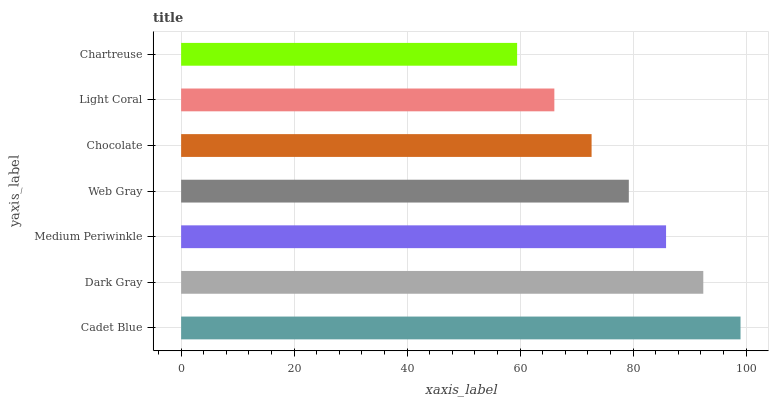Is Chartreuse the minimum?
Answer yes or no. Yes. Is Cadet Blue the maximum?
Answer yes or no. Yes. Is Dark Gray the minimum?
Answer yes or no. No. Is Dark Gray the maximum?
Answer yes or no. No. Is Cadet Blue greater than Dark Gray?
Answer yes or no. Yes. Is Dark Gray less than Cadet Blue?
Answer yes or no. Yes. Is Dark Gray greater than Cadet Blue?
Answer yes or no. No. Is Cadet Blue less than Dark Gray?
Answer yes or no. No. Is Web Gray the high median?
Answer yes or no. Yes. Is Web Gray the low median?
Answer yes or no. Yes. Is Dark Gray the high median?
Answer yes or no. No. Is Chartreuse the low median?
Answer yes or no. No. 